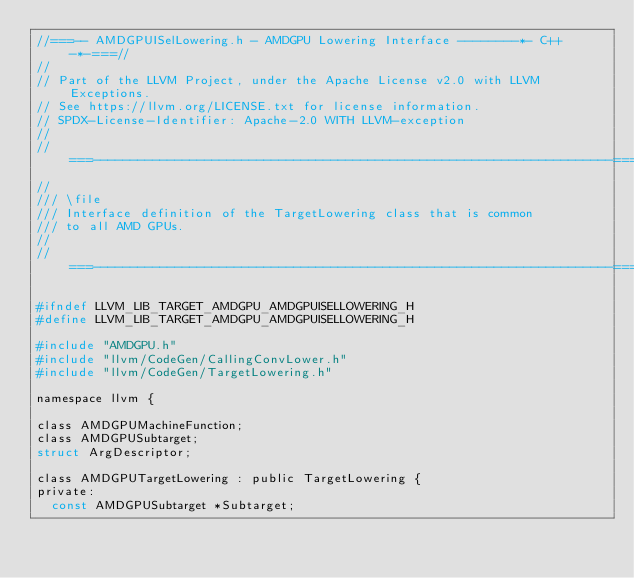<code> <loc_0><loc_0><loc_500><loc_500><_C_>//===-- AMDGPUISelLowering.h - AMDGPU Lowering Interface --------*- C++ -*-===//
//
// Part of the LLVM Project, under the Apache License v2.0 with LLVM Exceptions.
// See https://llvm.org/LICENSE.txt for license information.
// SPDX-License-Identifier: Apache-2.0 WITH LLVM-exception
//
//===----------------------------------------------------------------------===//
//
/// \file
/// Interface definition of the TargetLowering class that is common
/// to all AMD GPUs.
//
//===----------------------------------------------------------------------===//

#ifndef LLVM_LIB_TARGET_AMDGPU_AMDGPUISELLOWERING_H
#define LLVM_LIB_TARGET_AMDGPU_AMDGPUISELLOWERING_H

#include "AMDGPU.h"
#include "llvm/CodeGen/CallingConvLower.h"
#include "llvm/CodeGen/TargetLowering.h"

namespace llvm {

class AMDGPUMachineFunction;
class AMDGPUSubtarget;
struct ArgDescriptor;

class AMDGPUTargetLowering : public TargetLowering {
private:
  const AMDGPUSubtarget *Subtarget;
</code> 